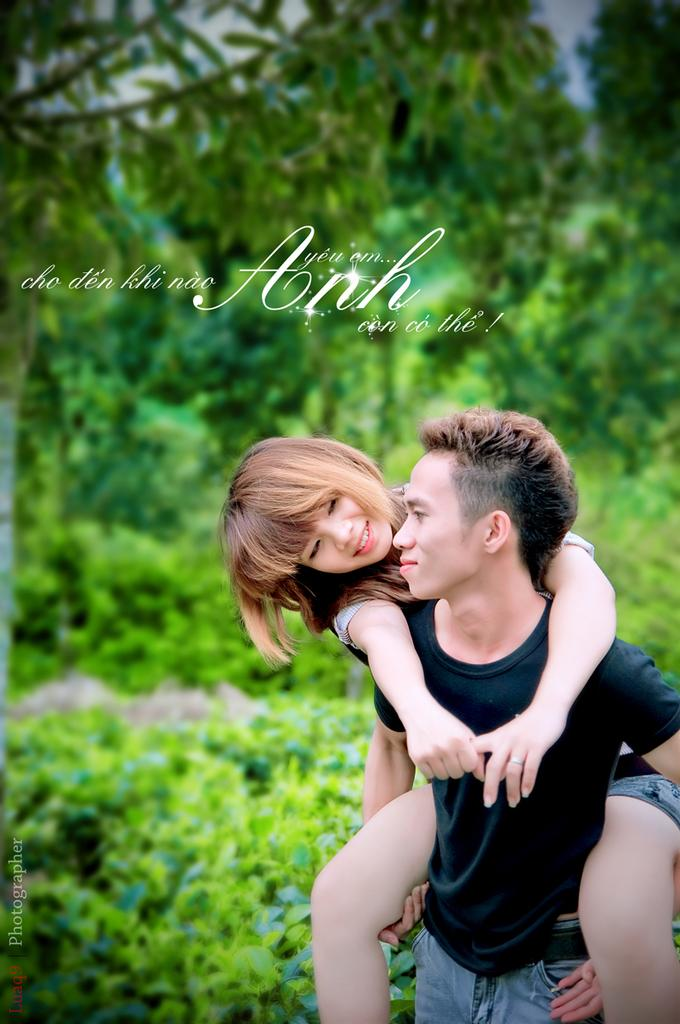What is featured in the image? There is a poster in the image. What is the main subject of the poster? The poster depicts a man carrying a girl on his shoulders. What can be seen in the background of the poster? There are trees in the background of the poster. How many ornaments are hanging from the trees in the image? There are no ornaments visible in the image; the trees are in the background of the poster, and the poster itself does not depict any ornaments. 